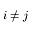<formula> <loc_0><loc_0><loc_500><loc_500>i \neq j</formula> 